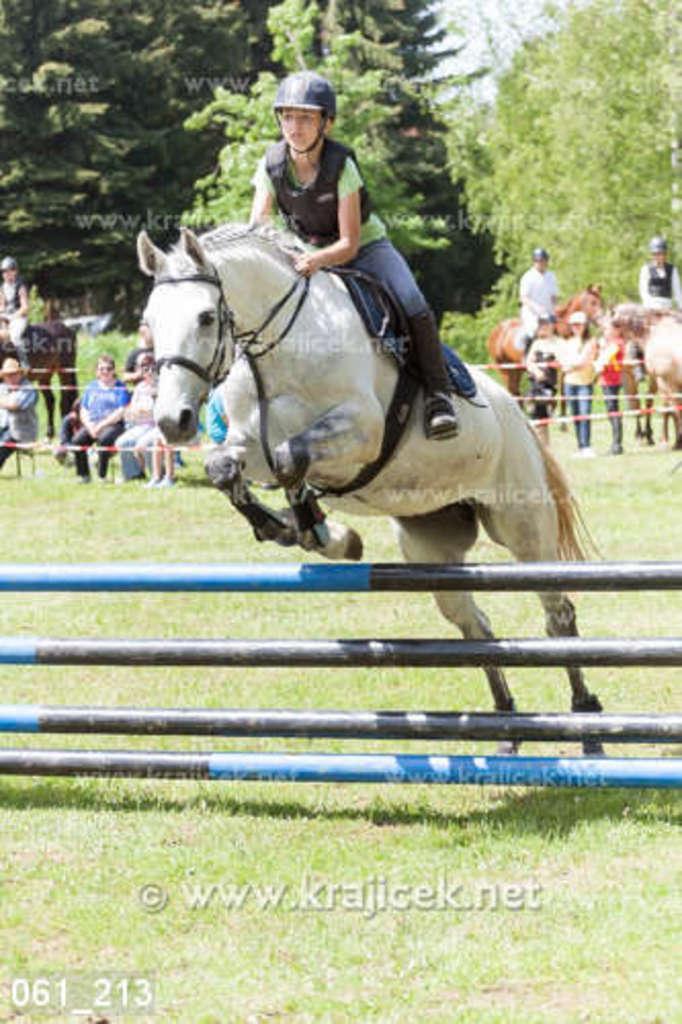Describe this image in one or two sentences. In this picture there is a girl on the horse in the center of the image and there are other people and trees in the background area of the image, there is a hurdle at the bottom side of the image. 